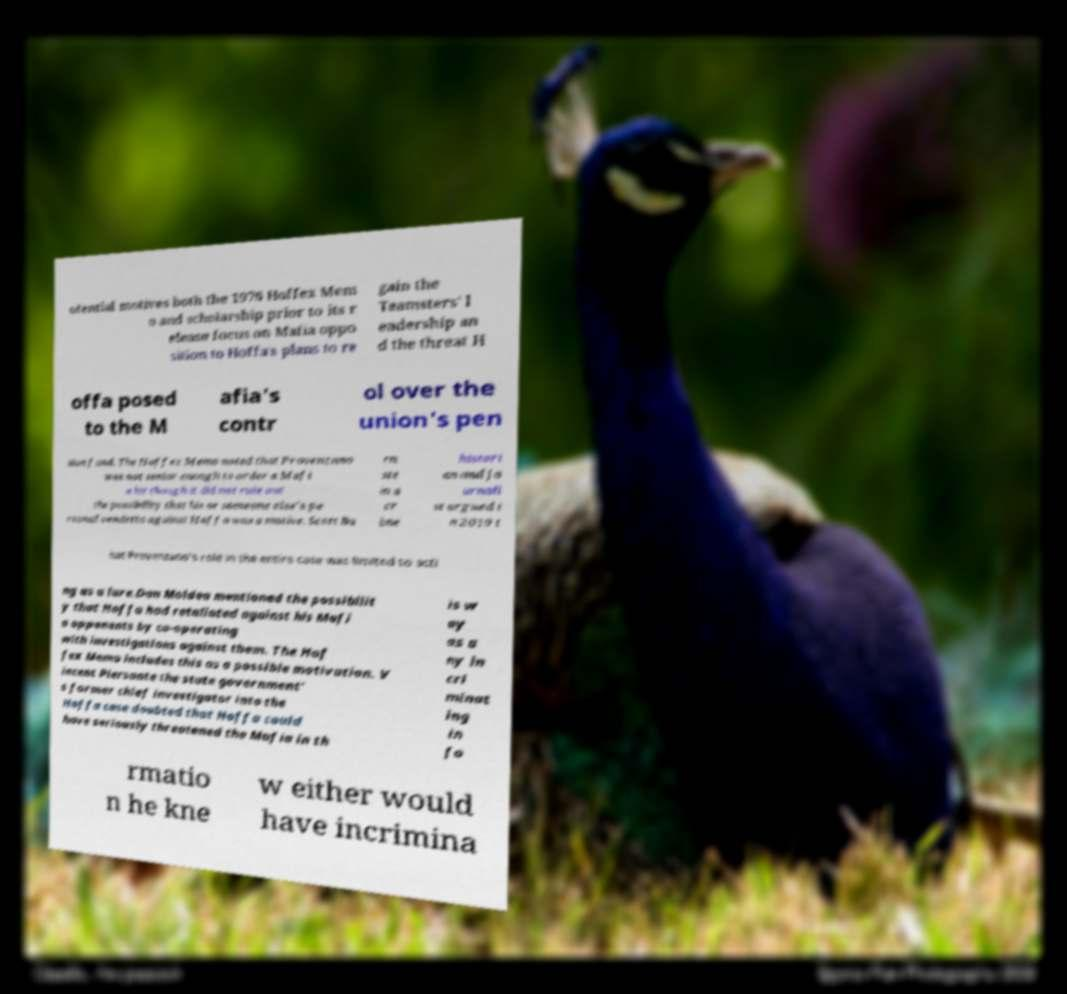There's text embedded in this image that I need extracted. Can you transcribe it verbatim? otential motives both the 1976 Hoffex Mem o and scholarship prior to its r elease focus on Mafia oppo sition to Hoffa's plans to re gain the Teamsters' l eadership an d the threat H offa posed to the M afia's contr ol over the union's pen sion fund. The Hoffex Memo noted that Provenzano was not senior enough to order a Mafi a hit though it did not rule out the possibility that his or someone else's pe rsonal vendetta against Hoffa was a motive. Scott Bu rn ste in a cr ime histori an and jo urnali st argued i n 2019 t hat Provenzano's role in the entire case was limited to acti ng as a lure.Dan Moldea mentioned the possibilit y that Hoffa had retaliated against his Mafi a opponents by co-operating with investigations against them. The Hof fex Memo includes this as a possible motivation. V incent Piersante the state government' s former chief investigator into the Hoffa case doubted that Hoffa could have seriously threatened the Mafia in th is w ay as a ny in cri minat ing in fo rmatio n he kne w either would have incrimina 